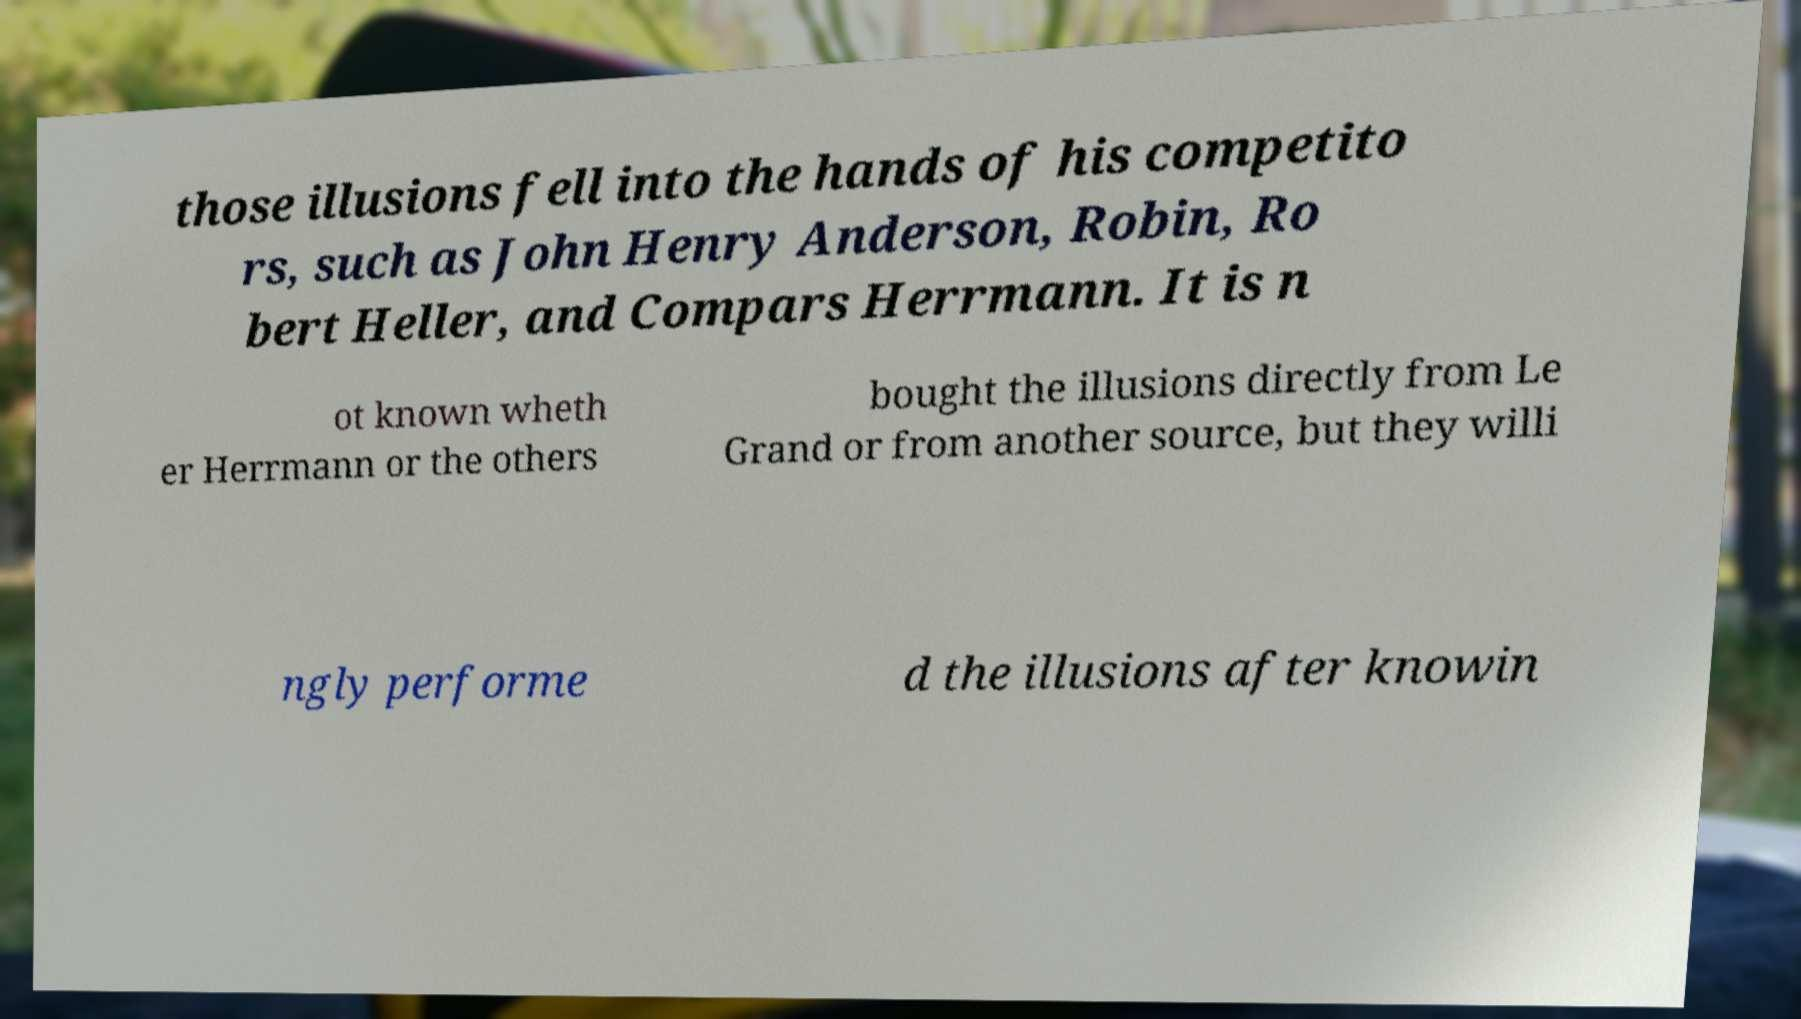Can you accurately transcribe the text from the provided image for me? those illusions fell into the hands of his competito rs, such as John Henry Anderson, Robin, Ro bert Heller, and Compars Herrmann. It is n ot known wheth er Herrmann or the others bought the illusions directly from Le Grand or from another source, but they willi ngly performe d the illusions after knowin 